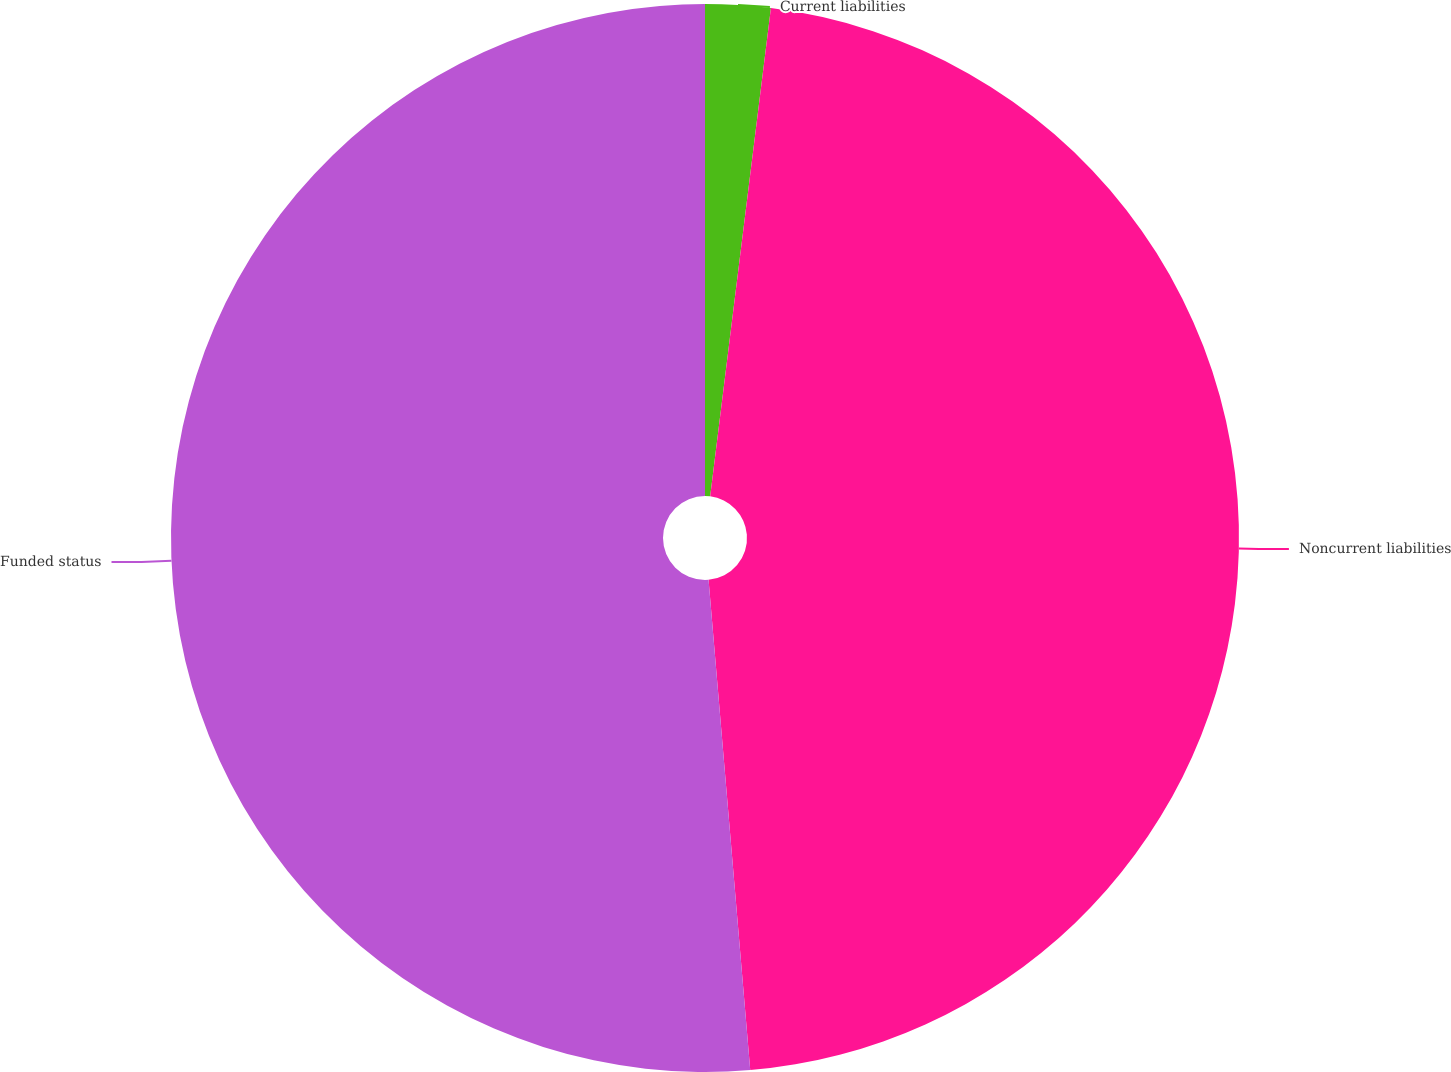Convert chart to OTSL. <chart><loc_0><loc_0><loc_500><loc_500><pie_chart><fcel>Current liabilities<fcel>Noncurrent liabilities<fcel>Funded status<nl><fcel>1.97%<fcel>46.68%<fcel>51.35%<nl></chart> 